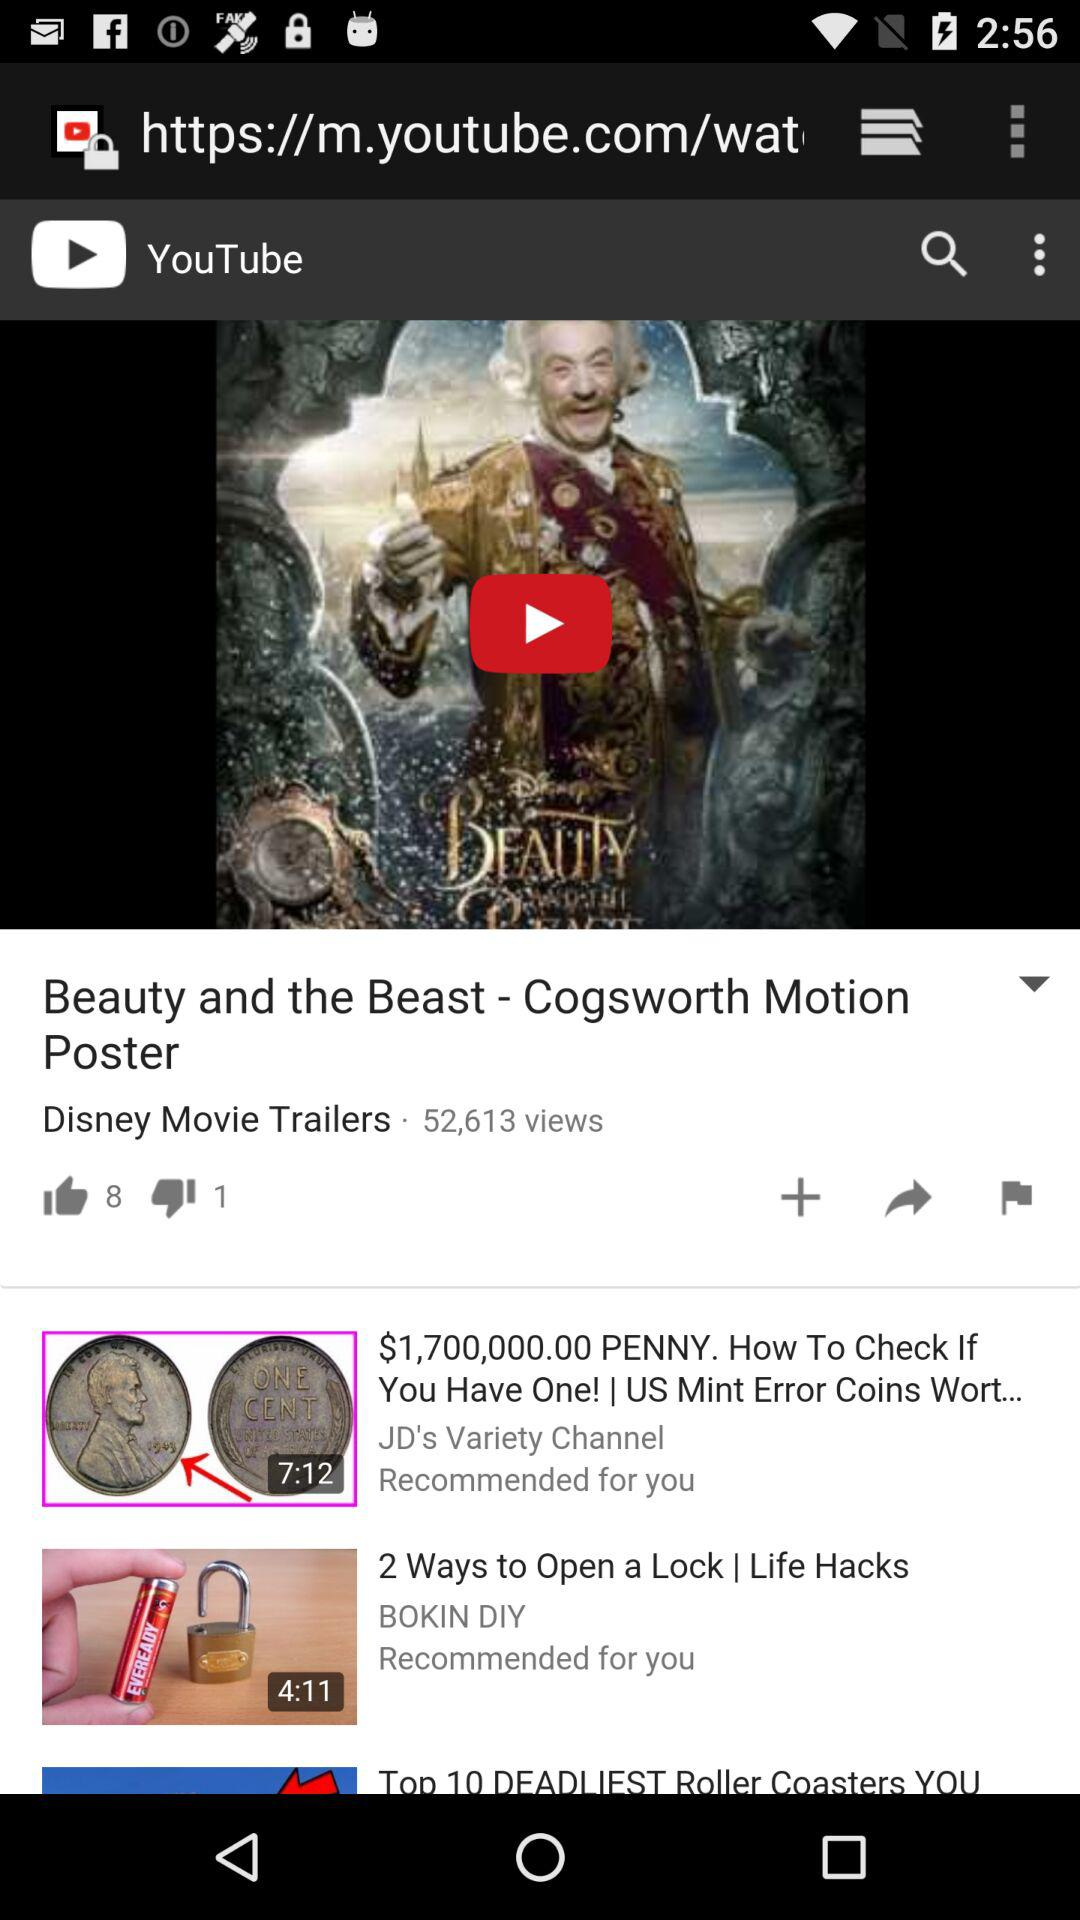What is the name of the current video in the player? The name of the current video in the player is "Beauty and the Beast - Cogsworth Motion Poster". 